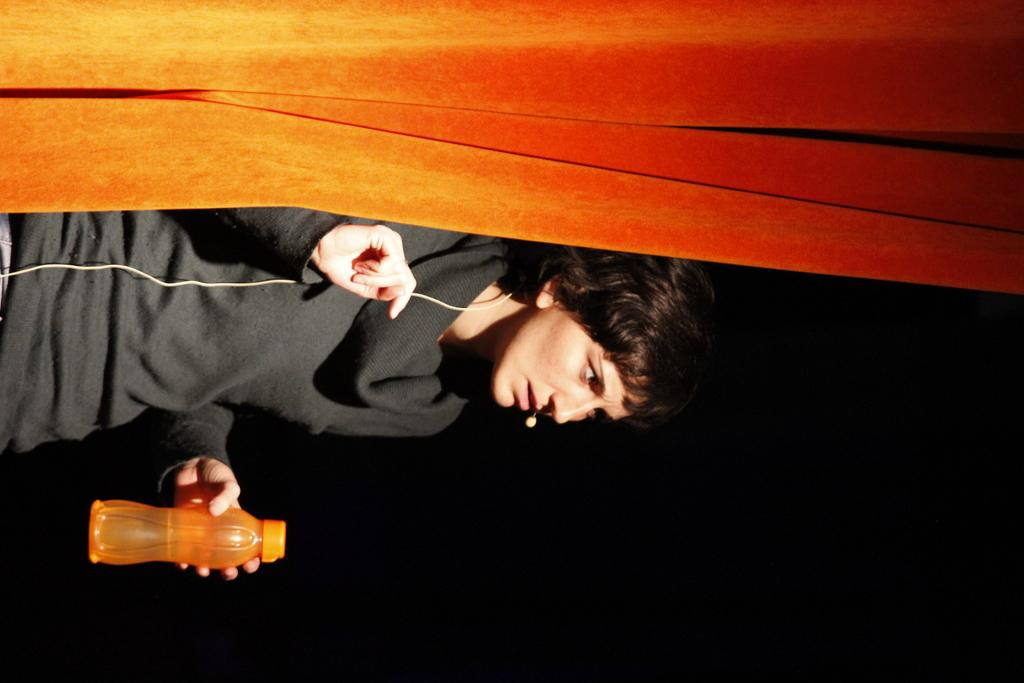Who is the main subject in the image? There is a woman in the image. What is the woman holding in the image? The woman is holding a water bottle. What is the woman wearing on her head in the image? The woman is wearing a headset. What is the woman lying on in the image? The woman is lying on a wooden wall. What type of berry can be seen growing on the wooden wall in the image? There is no berry visible in the image, as the woman is lying on a wooden wall. 